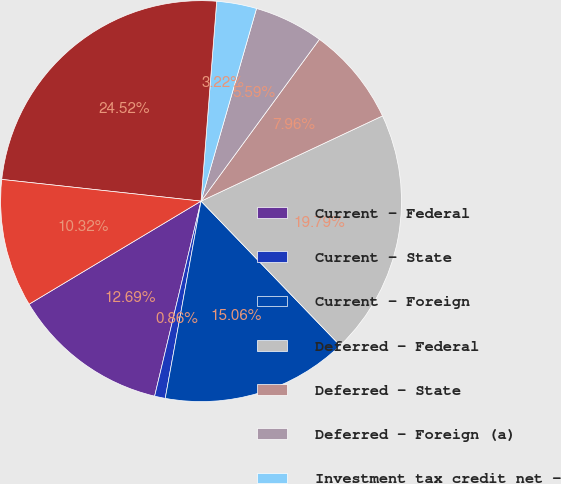<chart> <loc_0><loc_0><loc_500><loc_500><pie_chart><fcel>Current - Federal<fcel>Current - State<fcel>Current - Foreign<fcel>Deferred - Federal<fcel>Deferred - State<fcel>Deferred - Foreign (a)<fcel>Investment tax credit net -<fcel>Total income tax expense from<fcel>Total income tax expense -<nl><fcel>12.69%<fcel>0.86%<fcel>15.06%<fcel>19.79%<fcel>7.96%<fcel>5.59%<fcel>3.22%<fcel>24.52%<fcel>10.32%<nl></chart> 